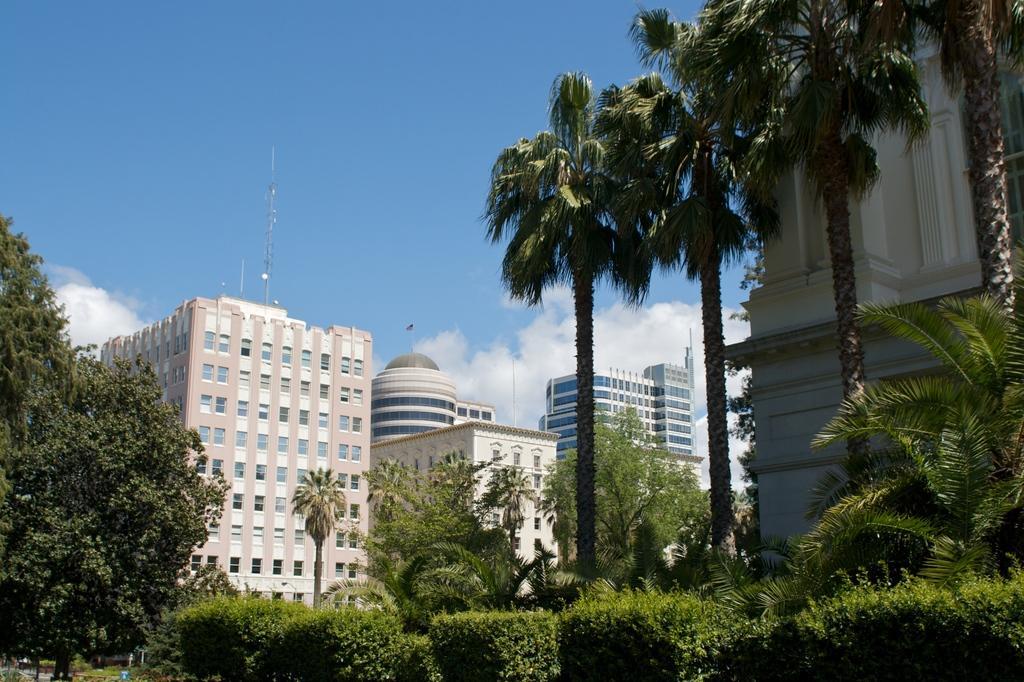Describe this image in one or two sentences. Here we can see plants, trees, poles, and buildings. In the background there is sky with clouds. 